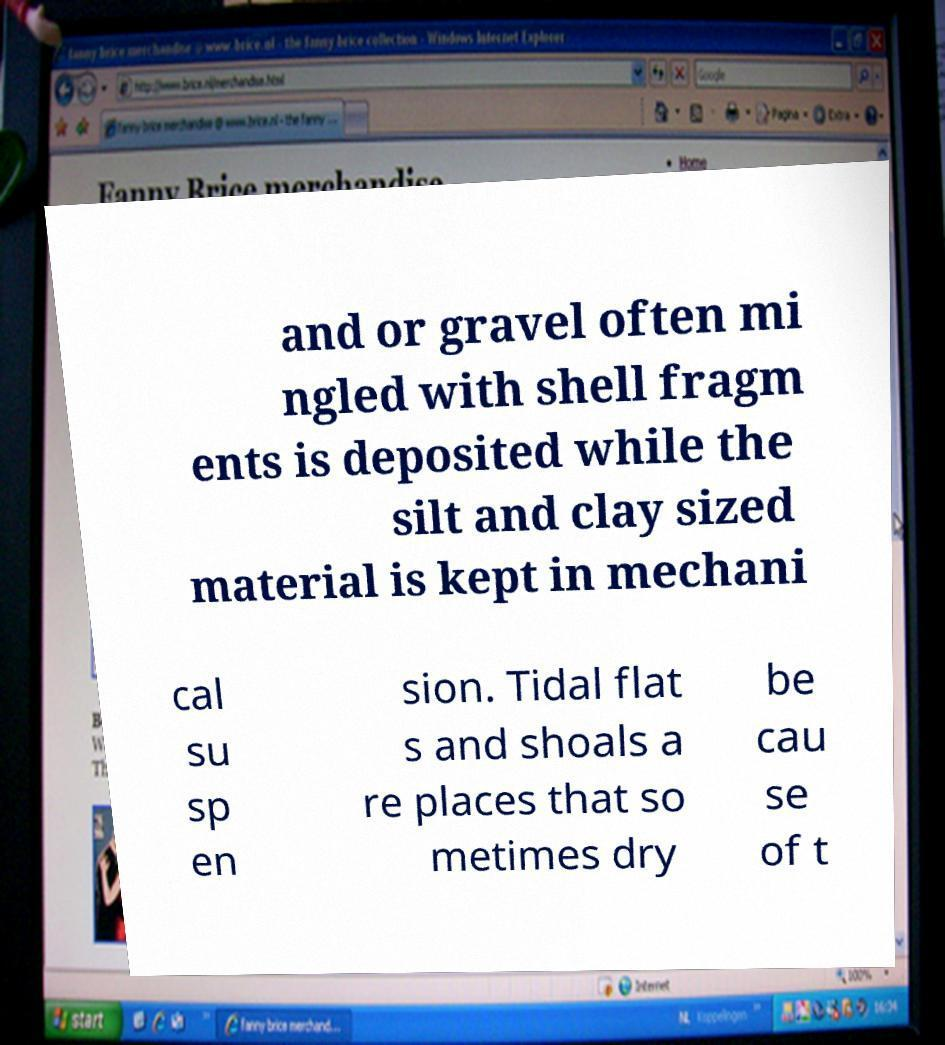Can you accurately transcribe the text from the provided image for me? and or gravel often mi ngled with shell fragm ents is deposited while the silt and clay sized material is kept in mechani cal su sp en sion. Tidal flat s and shoals a re places that so metimes dry be cau se of t 